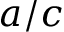<formula> <loc_0><loc_0><loc_500><loc_500>a / c</formula> 